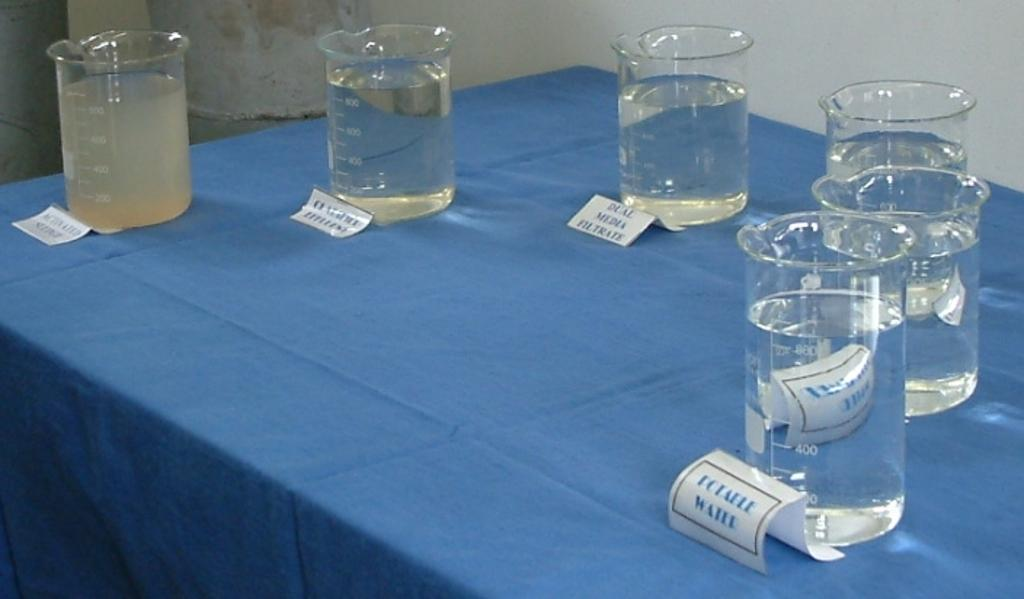<image>
Provide a brief description of the given image. A blue table has many different samples of filtrate 